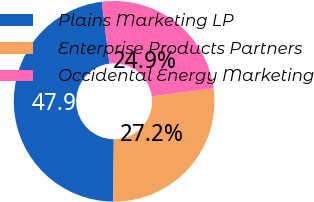<chart> <loc_0><loc_0><loc_500><loc_500><pie_chart><fcel>Plains Marketing LP<fcel>Enterprise Products Partners<fcel>Occidental Energy Marketing<nl><fcel>47.89%<fcel>27.2%<fcel>24.9%<nl></chart> 